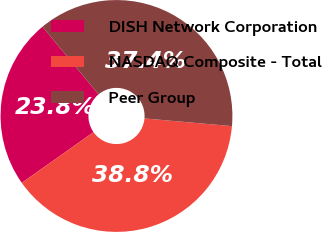Convert chart to OTSL. <chart><loc_0><loc_0><loc_500><loc_500><pie_chart><fcel>DISH Network Corporation<fcel>NASDAQ Composite - Total<fcel>Peer Group<nl><fcel>23.77%<fcel>38.82%<fcel>37.41%<nl></chart> 